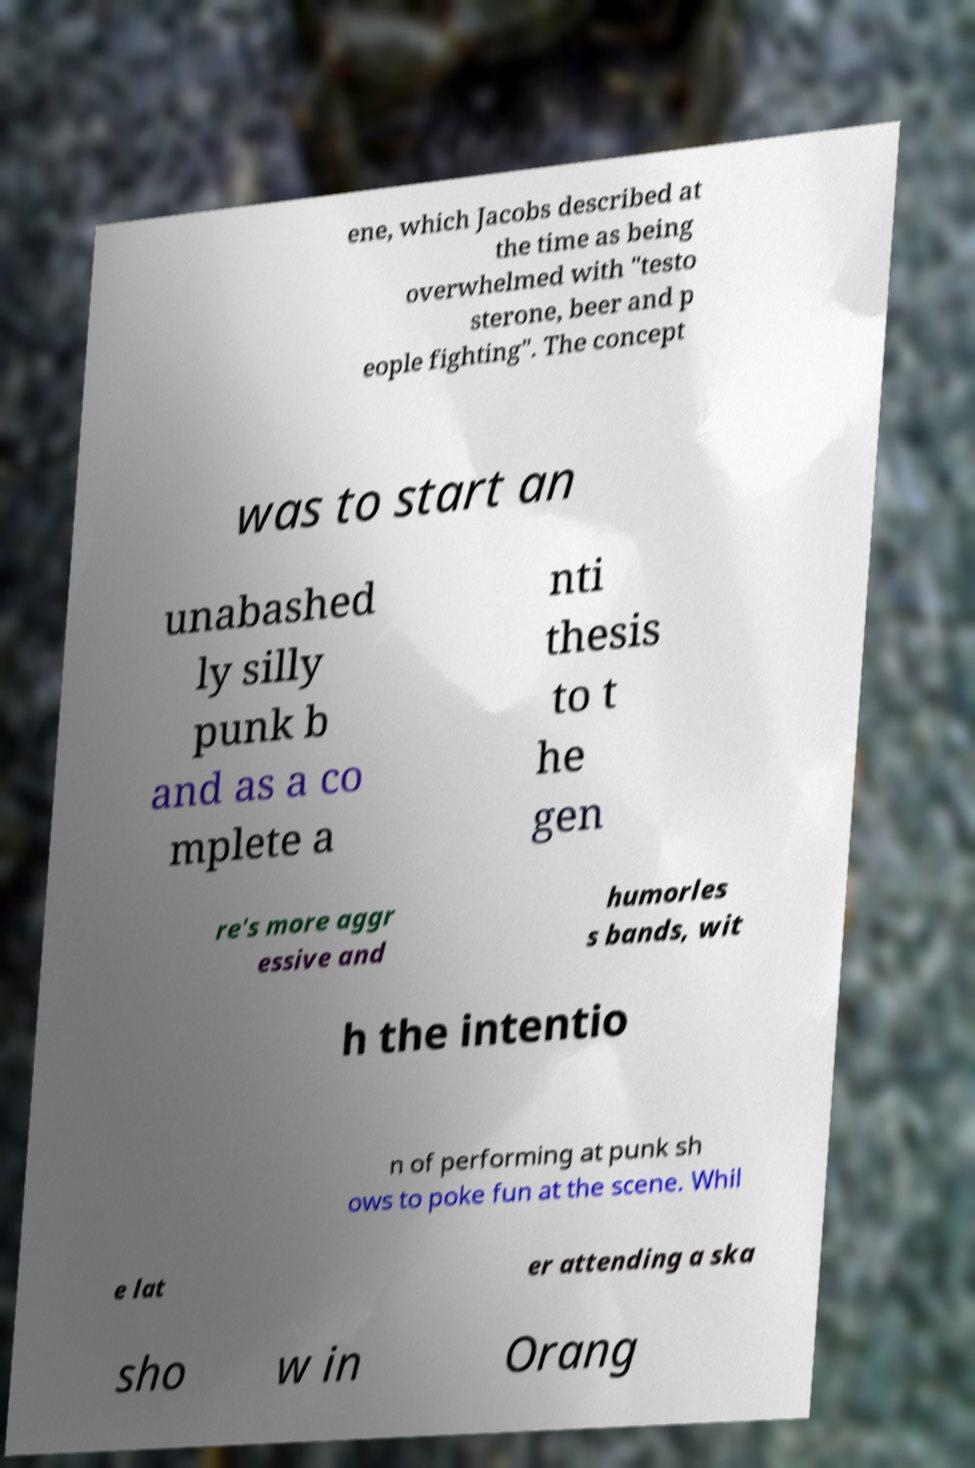What messages or text are displayed in this image? I need them in a readable, typed format. ene, which Jacobs described at the time as being overwhelmed with "testo sterone, beer and p eople fighting". The concept was to start an unabashed ly silly punk b and as a co mplete a nti thesis to t he gen re's more aggr essive and humorles s bands, wit h the intentio n of performing at punk sh ows to poke fun at the scene. Whil e lat er attending a ska sho w in Orang 